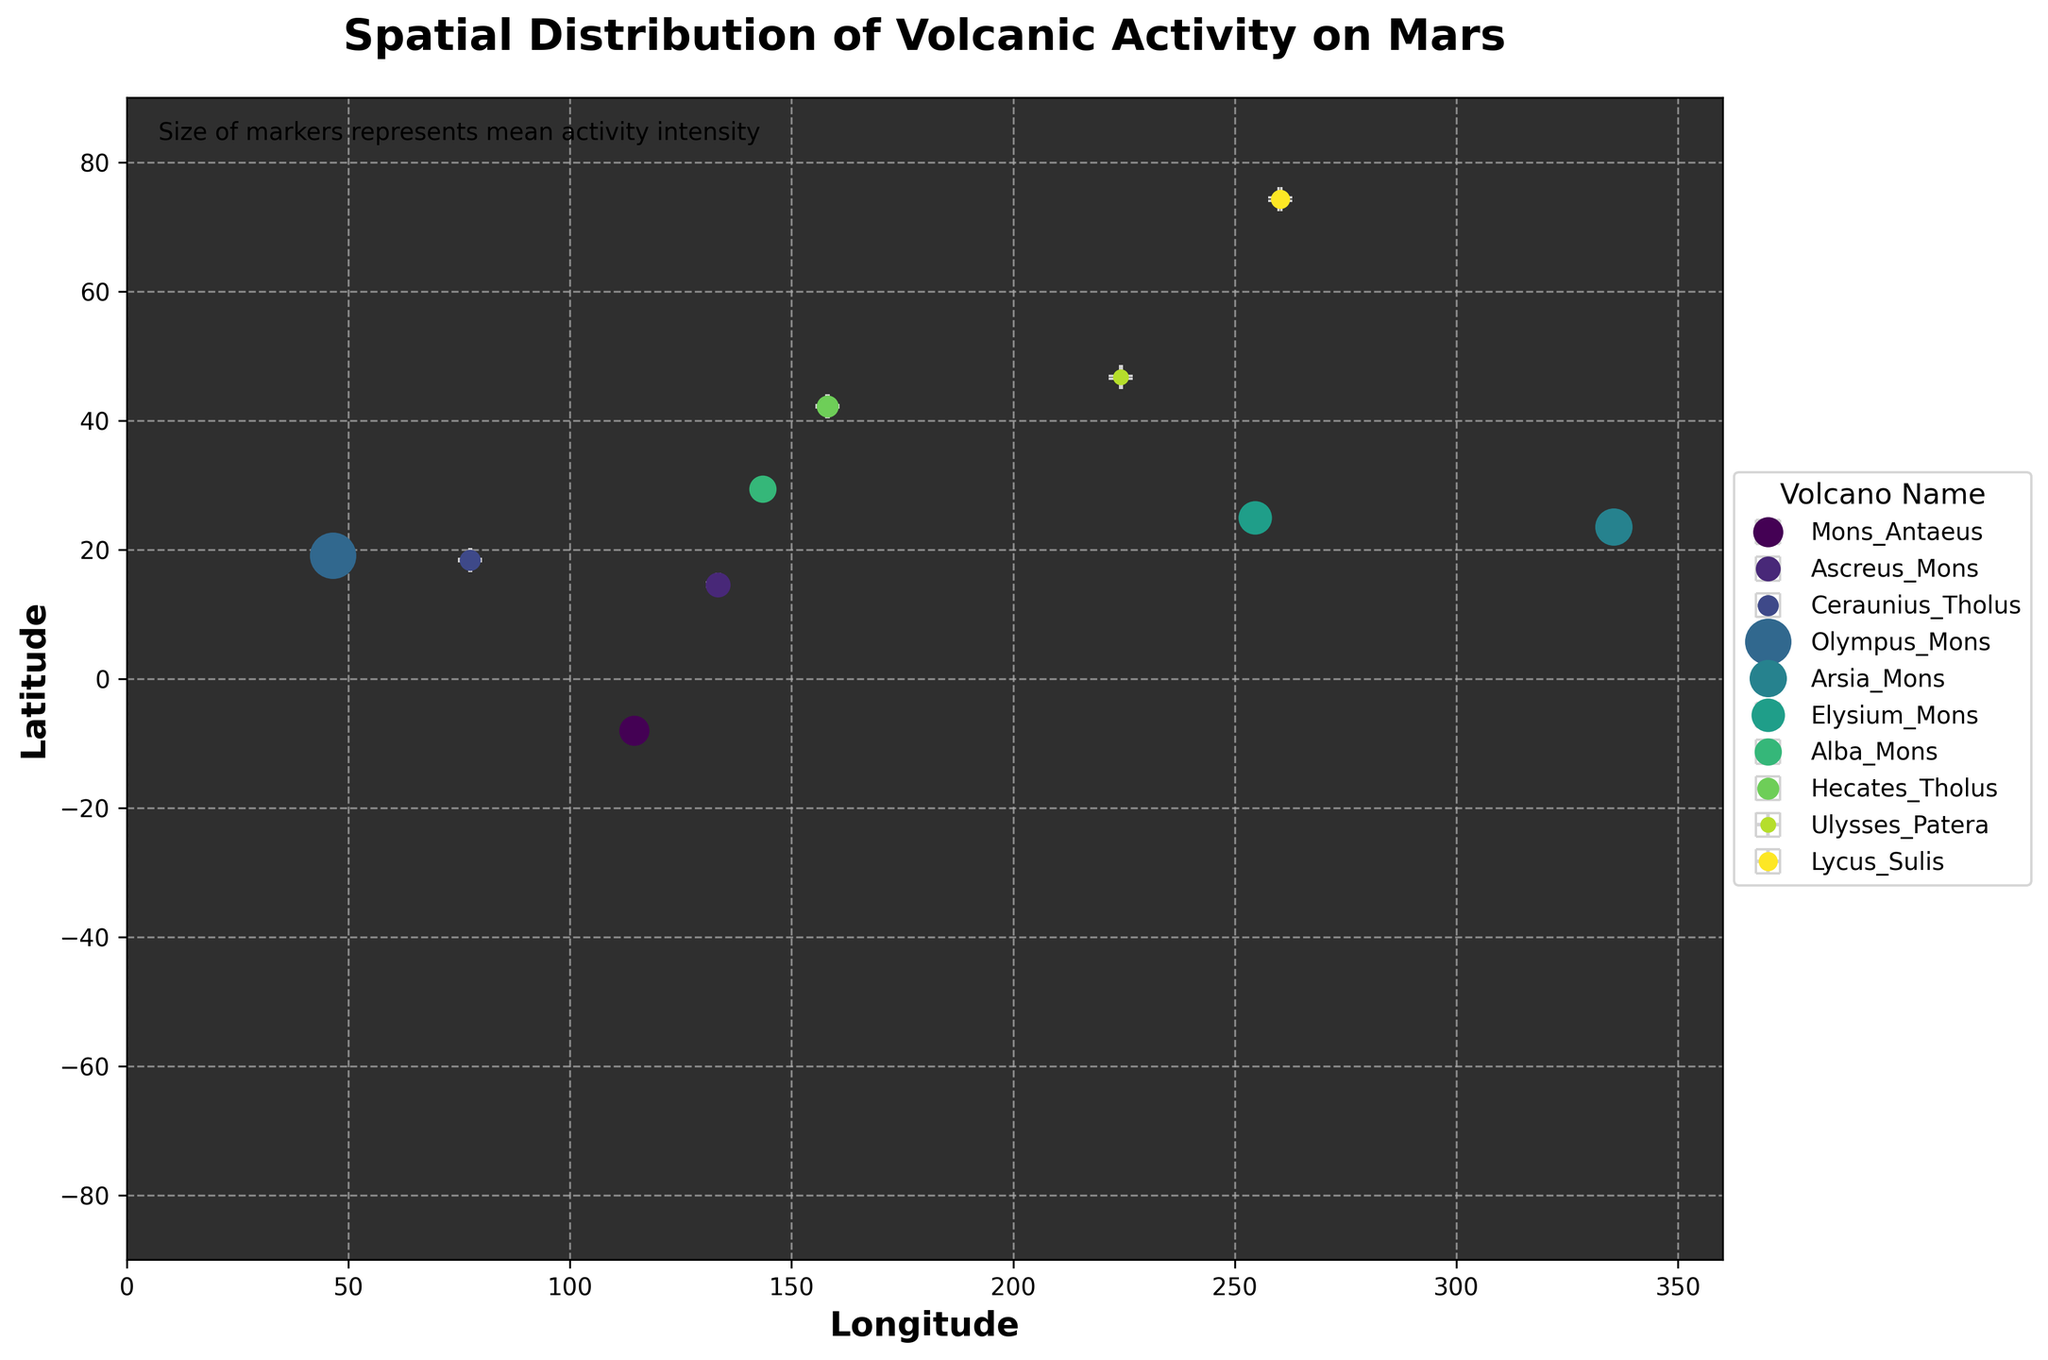What's the name of the volcano located at 19.1° latitude and 46.5° longitude? Identify the volcano by looking at the marker at the coordinates (19.1, 46.5) on the plot and refer to the legend for the name associated with that marker.
Answer: Olympus Mons Which volcano has the highest mean activity intensity on the plot? Locate the largest marker on the plot, which represents the highest mean activity intensity, and refer to the legend for its name.
Answer: Olympus Mons What is the mean activity intensity of Arsia Mons? Find the marker labeled Arsia Mons in the legend, then refer to the size of the marker to determine the mean activity intensity (use the legend and plot details if necessary).
Answer: 7.3 Are there any volcanoes in the northern hemisphere with a mean activity intensity greater than 6? Check the markers with latitude greater than 0° and identify any with sizes indicating a mean activity intensity greater than 6.
Answer: Yes, two (Arsia Mons and Elysium Mons) Which volcano has an activity intensity measurement with the smallest error margin? Compare the lengths of the error bars on each marker and identify the shortest one. Refer to the legend for the corresponding volcano name.
Answer: Ceraunius Tholus How do the error margins for Olympus Mons and Elysium Mons compare? Compare the error bars' lengths for Olympus Mons and Elysium Mons on the plot.
Answer: Olympus Mons has a larger error margin than Elysium Mons What is the average latitude of all the volcanoes plotted? Add up all the latitudes of the volcanoes and divide by the number of volcanoes: (-8.0 + 14.6 + 18.4 + 19.1 + 23.5 + 25.0 + 29.4 + 42.2 + 46.7 + 74.3)/10.
Answer: 28.22 How many volcanoes are located between longitudes 100° and 200°? Count the number of markers that fall within the longitude range of 100° to 200° on the plot.
Answer: 4 (Mons Antaeus, Ascreus Mons, Ceraunius Tholus, Alba Mons) Which volcano is represented by the marker closest to latitude 30° and longitude 150°? Identify the marker closest to the coordinates (30, 150) and refer to the legend for the name.
Answer: Alba Mons What is the total range of latitudes covered by the volcanoes in the plot? Find the difference between the highest (74.3) and lowest (-8.0) latitudes of the volcanoes.
Answer: 82.3 